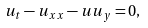Convert formula to latex. <formula><loc_0><loc_0><loc_500><loc_500>u _ { t } - u _ { x x } - u u _ { y } = 0 ,</formula> 